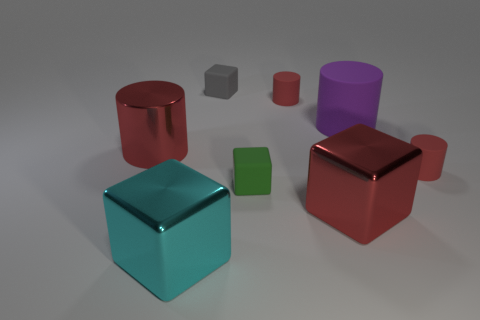Is there another big thing of the same shape as the purple object?
Provide a short and direct response. Yes. What is the shape of the red rubber object on the left side of the small red thing that is in front of the big red shiny cylinder?
Provide a short and direct response. Cylinder. What color is the matte block in front of the big purple cylinder?
Make the answer very short. Green. What size is the green block that is the same material as the gray object?
Your answer should be compact. Small. There is another rubber object that is the same shape as the green thing; what is its size?
Give a very brief answer. Small. Are any large purple things visible?
Your answer should be very brief. Yes. How many objects are tiny cubes that are in front of the gray matte thing or big cyan metal spheres?
Provide a short and direct response. 1. There is a green thing that is the same size as the gray matte block; what is its material?
Provide a succinct answer. Rubber. There is a tiny cylinder that is on the left side of the tiny rubber cylinder to the right of the red shiny cube; what is its color?
Make the answer very short. Red. There is a big cyan metal object; what number of large metallic objects are left of it?
Ensure brevity in your answer.  1. 